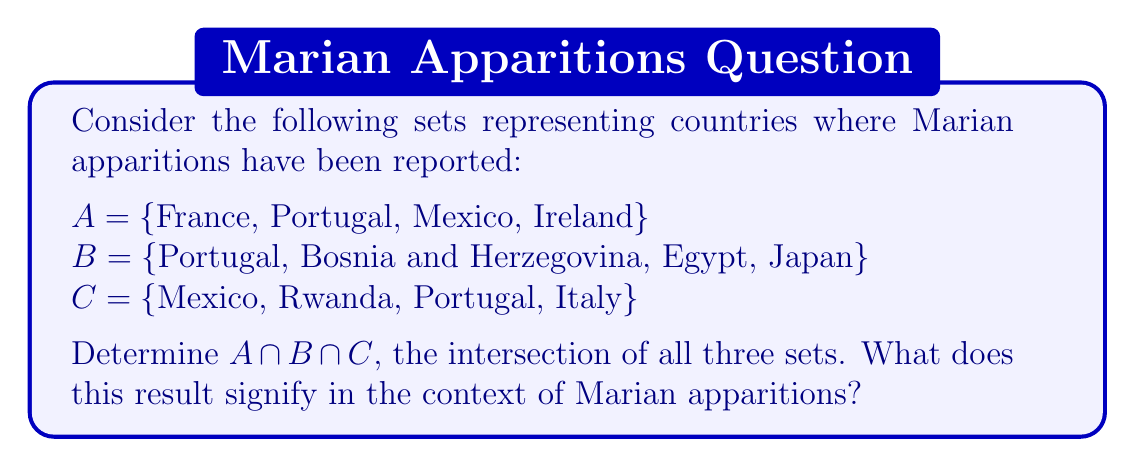Show me your answer to this math problem. To find the intersection of sets A, B, and C, we need to identify the elements that are common to all three sets. Let's approach this step-by-step:

1. First, let's list out the elements of each set:
   $A = \{France, Portugal, Mexico, Ireland\}$
   $B = \{Portugal, Bosnia and Herzegovina, Egypt, Japan\}$
   $C = \{Mexico, Rwanda, Portugal, Italy\}$

2. Now, we need to find the elements that appear in all three sets. We can do this by checking each element:

   - France: Only in A
   - Portugal: In A, B, and C
   - Mexico: In A and C, but not B
   - Ireland: Only in A
   - Bosnia and Herzegovina: Only in B
   - Egypt: Only in B
   - Japan: Only in B
   - Rwanda: Only in C
   - Italy: Only in C

3. We can see that the only element that appears in all three sets is Portugal.

4. Therefore, $A \cap B \cap C = \{Portugal\}$

In the context of Marian apparitions, this result signifies that among the countries represented in these sets, Portugal is the only country where Marian apparitions have been reported that is common to all three sets. This likely refers to the famous apparitions of Our Lady of Fátima in Portugal, which is one of the most well-known and widely recognized Marian apparitions in Catholic tradition.
Answer: $A \cap B \cap C = \{Portugal\}$ 